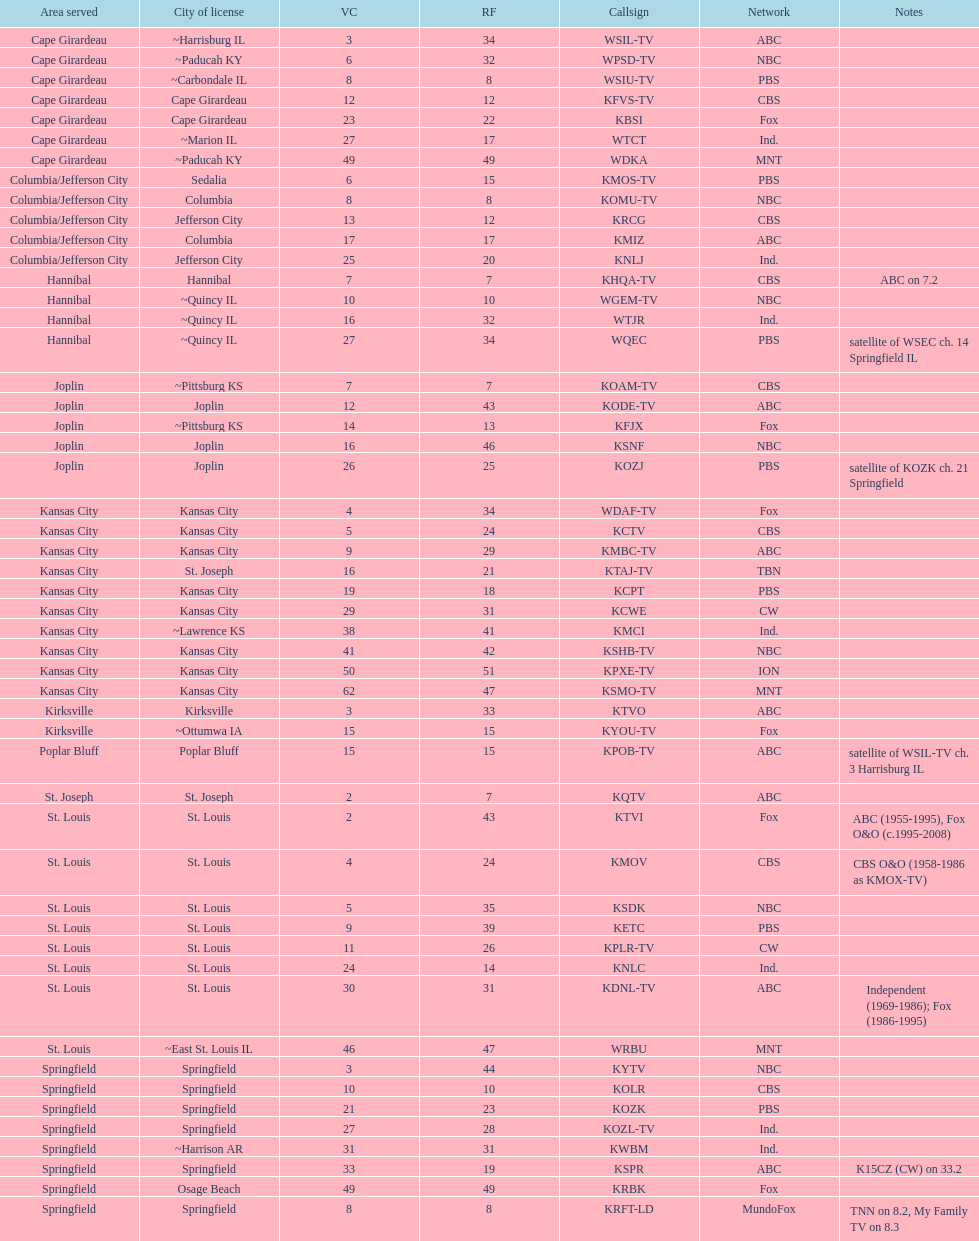Which station possesses a license in the same city as koam-tv? KFJX. Can you give me this table as a dict? {'header': ['Area served', 'City of license', 'VC', 'RF', 'Callsign', 'Network', 'Notes'], 'rows': [['Cape Girardeau', '~Harrisburg IL', '3', '34', 'WSIL-TV', 'ABC', ''], ['Cape Girardeau', '~Paducah KY', '6', '32', 'WPSD-TV', 'NBC', ''], ['Cape Girardeau', '~Carbondale IL', '8', '8', 'WSIU-TV', 'PBS', ''], ['Cape Girardeau', 'Cape Girardeau', '12', '12', 'KFVS-TV', 'CBS', ''], ['Cape Girardeau', 'Cape Girardeau', '23', '22', 'KBSI', 'Fox', ''], ['Cape Girardeau', '~Marion IL', '27', '17', 'WTCT', 'Ind.', ''], ['Cape Girardeau', '~Paducah KY', '49', '49', 'WDKA', 'MNT', ''], ['Columbia/Jefferson City', 'Sedalia', '6', '15', 'KMOS-TV', 'PBS', ''], ['Columbia/Jefferson City', 'Columbia', '8', '8', 'KOMU-TV', 'NBC', ''], ['Columbia/Jefferson City', 'Jefferson City', '13', '12', 'KRCG', 'CBS', ''], ['Columbia/Jefferson City', 'Columbia', '17', '17', 'KMIZ', 'ABC', ''], ['Columbia/Jefferson City', 'Jefferson City', '25', '20', 'KNLJ', 'Ind.', ''], ['Hannibal', 'Hannibal', '7', '7', 'KHQA-TV', 'CBS', 'ABC on 7.2'], ['Hannibal', '~Quincy IL', '10', '10', 'WGEM-TV', 'NBC', ''], ['Hannibal', '~Quincy IL', '16', '32', 'WTJR', 'Ind.', ''], ['Hannibal', '~Quincy IL', '27', '34', 'WQEC', 'PBS', 'satellite of WSEC ch. 14 Springfield IL'], ['Joplin', '~Pittsburg KS', '7', '7', 'KOAM-TV', 'CBS', ''], ['Joplin', 'Joplin', '12', '43', 'KODE-TV', 'ABC', ''], ['Joplin', '~Pittsburg KS', '14', '13', 'KFJX', 'Fox', ''], ['Joplin', 'Joplin', '16', '46', 'KSNF', 'NBC', ''], ['Joplin', 'Joplin', '26', '25', 'KOZJ', 'PBS', 'satellite of KOZK ch. 21 Springfield'], ['Kansas City', 'Kansas City', '4', '34', 'WDAF-TV', 'Fox', ''], ['Kansas City', 'Kansas City', '5', '24', 'KCTV', 'CBS', ''], ['Kansas City', 'Kansas City', '9', '29', 'KMBC-TV', 'ABC', ''], ['Kansas City', 'St. Joseph', '16', '21', 'KTAJ-TV', 'TBN', ''], ['Kansas City', 'Kansas City', '19', '18', 'KCPT', 'PBS', ''], ['Kansas City', 'Kansas City', '29', '31', 'KCWE', 'CW', ''], ['Kansas City', '~Lawrence KS', '38', '41', 'KMCI', 'Ind.', ''], ['Kansas City', 'Kansas City', '41', '42', 'KSHB-TV', 'NBC', ''], ['Kansas City', 'Kansas City', '50', '51', 'KPXE-TV', 'ION', ''], ['Kansas City', 'Kansas City', '62', '47', 'KSMO-TV', 'MNT', ''], ['Kirksville', 'Kirksville', '3', '33', 'KTVO', 'ABC', ''], ['Kirksville', '~Ottumwa IA', '15', '15', 'KYOU-TV', 'Fox', ''], ['Poplar Bluff', 'Poplar Bluff', '15', '15', 'KPOB-TV', 'ABC', 'satellite of WSIL-TV ch. 3 Harrisburg IL'], ['St. Joseph', 'St. Joseph', '2', '7', 'KQTV', 'ABC', ''], ['St. Louis', 'St. Louis', '2', '43', 'KTVI', 'Fox', 'ABC (1955-1995), Fox O&O (c.1995-2008)'], ['St. Louis', 'St. Louis', '4', '24', 'KMOV', 'CBS', 'CBS O&O (1958-1986 as KMOX-TV)'], ['St. Louis', 'St. Louis', '5', '35', 'KSDK', 'NBC', ''], ['St. Louis', 'St. Louis', '9', '39', 'KETC', 'PBS', ''], ['St. Louis', 'St. Louis', '11', '26', 'KPLR-TV', 'CW', ''], ['St. Louis', 'St. Louis', '24', '14', 'KNLC', 'Ind.', ''], ['St. Louis', 'St. Louis', '30', '31', 'KDNL-TV', 'ABC', 'Independent (1969-1986); Fox (1986-1995)'], ['St. Louis', '~East St. Louis IL', '46', '47', 'WRBU', 'MNT', ''], ['Springfield', 'Springfield', '3', '44', 'KYTV', 'NBC', ''], ['Springfield', 'Springfield', '10', '10', 'KOLR', 'CBS', ''], ['Springfield', 'Springfield', '21', '23', 'KOZK', 'PBS', ''], ['Springfield', 'Springfield', '27', '28', 'KOZL-TV', 'Ind.', ''], ['Springfield', '~Harrison AR', '31', '31', 'KWBM', 'Ind.', ''], ['Springfield', 'Springfield', '33', '19', 'KSPR', 'ABC', 'K15CZ (CW) on 33.2'], ['Springfield', 'Osage Beach', '49', '49', 'KRBK', 'Fox', ''], ['Springfield', 'Springfield', '8', '8', 'KRFT-LD', 'MundoFox', 'TNN on 8.2, My Family TV on 8.3']]} 